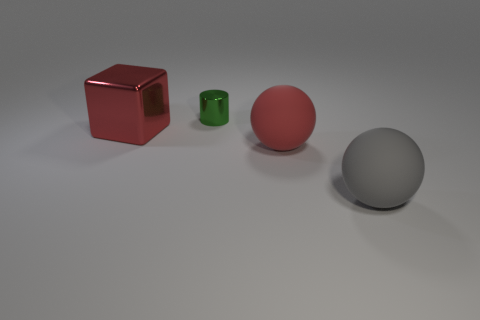There is a shiny object behind the big metal thing that is on the left side of the green cylinder; what is its color?
Offer a very short reply. Green. How many other objects are there of the same color as the cube?
Offer a very short reply. 1. How big is the cylinder?
Keep it short and to the point. Small. Is the number of matte spheres to the right of the large red ball greater than the number of red shiny things in front of the big red metal thing?
Offer a terse response. Yes. There is a shiny object right of the large metallic block; what number of rubber balls are to the right of it?
Provide a succinct answer. 2. Is the shape of the large gray thing in front of the red matte thing the same as  the green shiny thing?
Ensure brevity in your answer.  No. There is another thing that is the same shape as the gray thing; what is its material?
Offer a very short reply. Rubber. What number of green objects have the same size as the green cylinder?
Your answer should be compact. 0. There is a big object that is left of the gray matte thing and on the right side of the metal cube; what color is it?
Give a very brief answer. Red. Are there fewer purple rubber blocks than large red rubber balls?
Provide a short and direct response. Yes. 